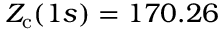<formula> <loc_0><loc_0><loc_500><loc_500>Z _ { c } ( 1 s ) = 1 7 0 . 2 6</formula> 